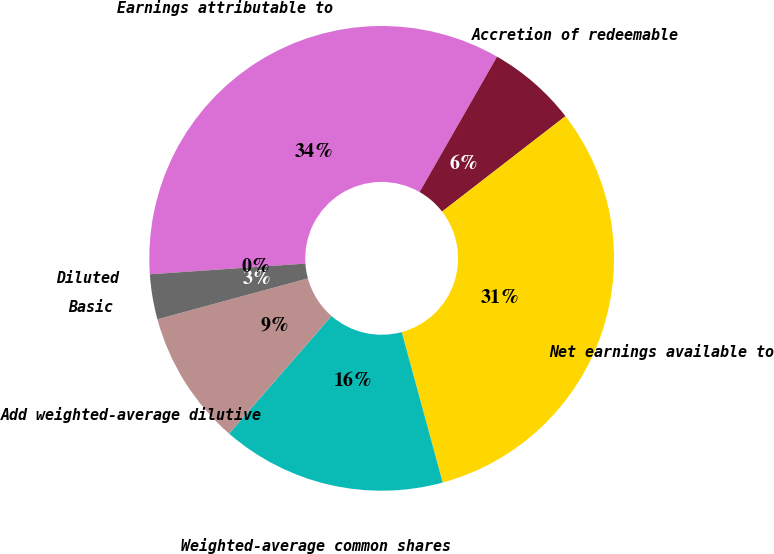Convert chart to OTSL. <chart><loc_0><loc_0><loc_500><loc_500><pie_chart><fcel>Earnings attributable to<fcel>Accretion of redeemable<fcel>Net earnings available to<fcel>Weighted-average common shares<fcel>Add weighted-average dilutive<fcel>Basic<fcel>Diluted<nl><fcel>34.37%<fcel>6.25%<fcel>31.25%<fcel>15.63%<fcel>9.38%<fcel>3.13%<fcel>0.0%<nl></chart> 